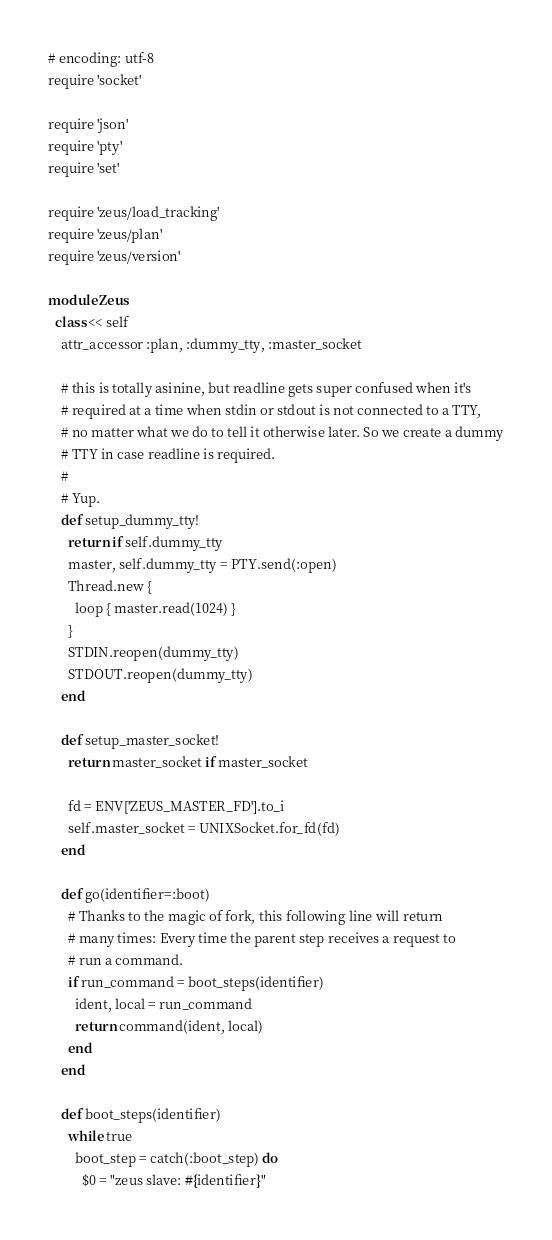<code> <loc_0><loc_0><loc_500><loc_500><_Ruby_># encoding: utf-8
require 'socket'

require 'json'
require 'pty'
require 'set'

require 'zeus/load_tracking'
require 'zeus/plan'
require 'zeus/version'

module Zeus
  class << self
    attr_accessor :plan, :dummy_tty, :master_socket

    # this is totally asinine, but readline gets super confused when it's
    # required at a time when stdin or stdout is not connected to a TTY,
    # no matter what we do to tell it otherwise later. So we create a dummy
    # TTY in case readline is required.
    #
    # Yup.
    def setup_dummy_tty!
      return if self.dummy_tty
      master, self.dummy_tty = PTY.send(:open)
      Thread.new {
        loop { master.read(1024) }
      }
      STDIN.reopen(dummy_tty)
      STDOUT.reopen(dummy_tty)
    end

    def setup_master_socket!
      return master_socket if master_socket

      fd = ENV['ZEUS_MASTER_FD'].to_i
      self.master_socket = UNIXSocket.for_fd(fd)
    end

    def go(identifier=:boot)
      # Thanks to the magic of fork, this following line will return
      # many times: Every time the parent step receives a request to
      # run a command.
      if run_command = boot_steps(identifier)
        ident, local = run_command
        return command(ident, local)
      end
    end

    def boot_steps(identifier)
      while true
        boot_step = catch(:boot_step) do
          $0 = "zeus slave: #{identifier}"
</code> 